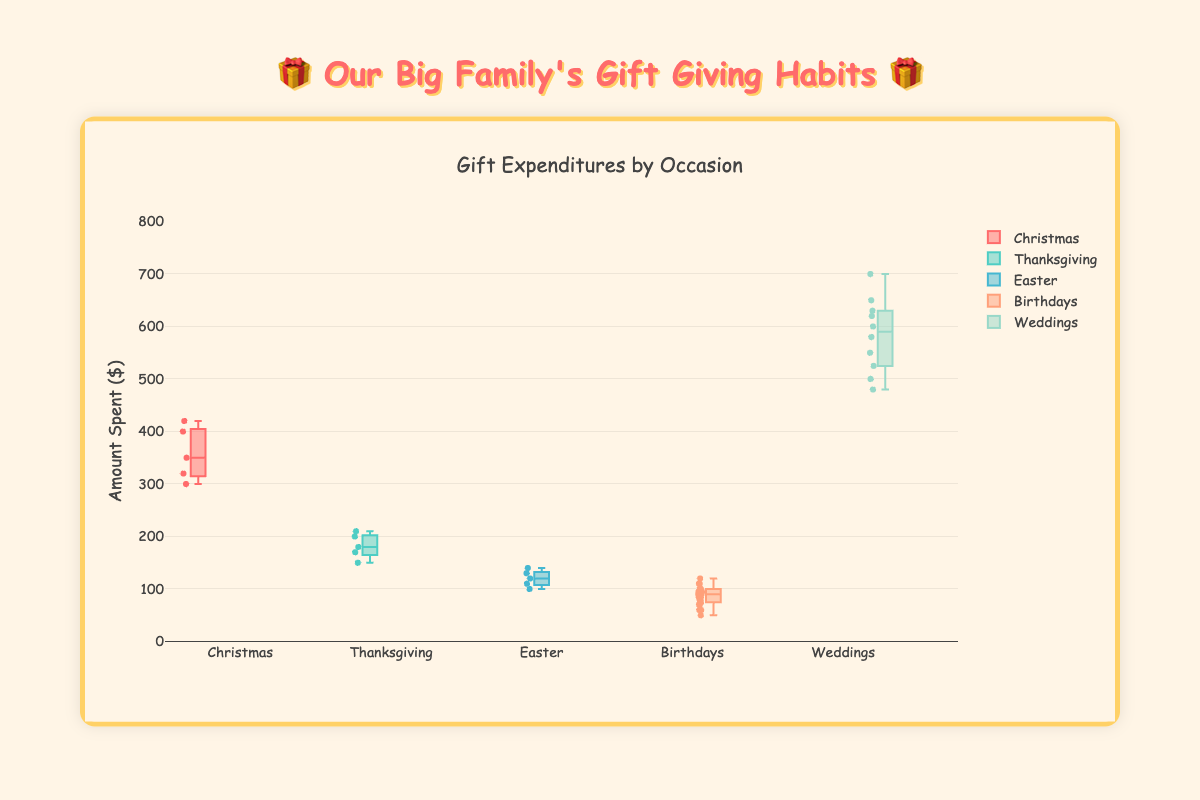What are the different occasions shown in the box plot? The title of the boxes at the bottom of the plot list the different occasions. They are: Christmas, Thanksgiving, Easter, Birthdays, and Weddings.
Answer: Christmas, Thanksgiving, Easter, Birthdays, Weddings Which occasion has the highest maximum expenditure? By looking at the top-most points of each box, we see that Weddings have the highest maximum value among all the occasions.
Answer: Weddings What is the median value for Christmas expenditures? The median is indicated by the line inside each box. For Christmas, observe the position of this line within the Christmas box plot.
Answer: 350 Which family spends the most on Birthdays? By reviewing the spread of points for each family within the Birthdays' box, the highest individual points will indicate the family spending the most. The Browns have the highest expenditure at 120 on Birthdays.
Answer: Browns What is the interquartile range (IQR) for Thanksgiving expenditures? The IQR is the range between the first quartile (25th percentile) and the third quartile (75th percentile). For Thanksgiving, observe the bottom and top of the box edges and calculate the difference.
Answer: 180-150 = 30 Compare the median expenditures for Easter and Thanksgiving. Which one is higher? Check the median lines inside the boxes for Easter and Thanksgiving. The Thanksgiving box's median line is higher than Easter's median line.
Answer: Thanksgiving What is the range of the data for Wedding expenditures? The range is the distance between the minimum and maximum values. For Weddings, the lowest value is 480 and the highest is 700. So, the range is 700 - 480.
Answer: 220 Which occasion has the least variation in gift expenditures? Variation in expenditures can be determined by looking at the size of the boxes and the spread of the points. The Easter box seems to have the least spread and is the smallest, indicating the least variation.
Answer: Easter Is it true that all families spend more on Weddings compared to Christmas? Compare the medians for Wedding and Christmas expenditures across the families. For each family, the median expenditure on Weddings is higher than on Christmas.
Answer: True 